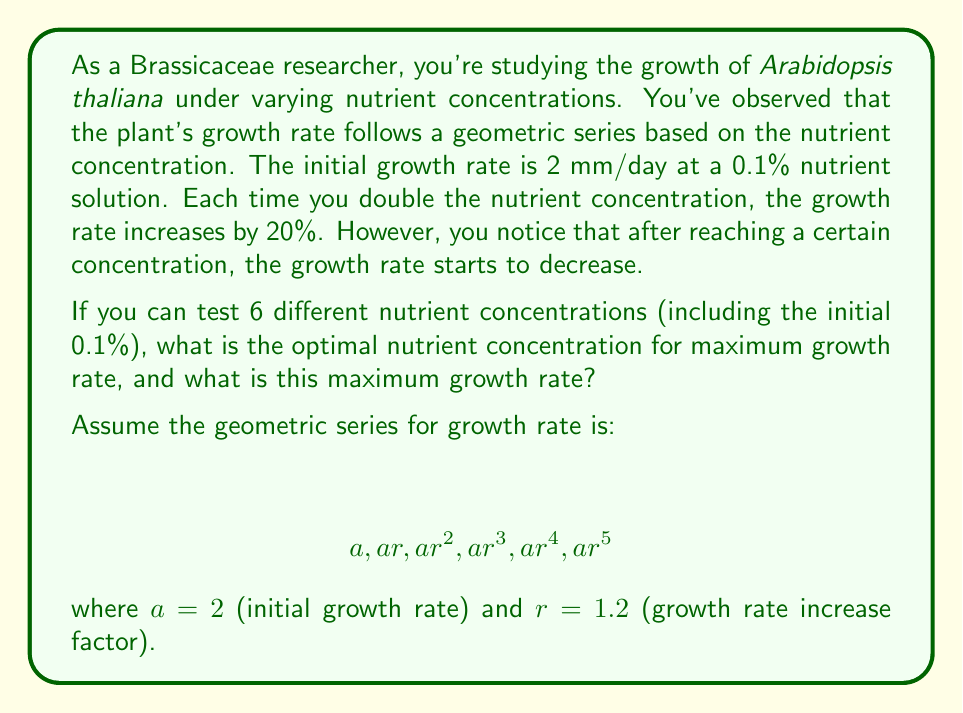Could you help me with this problem? Let's approach this step-by-step:

1) First, we need to calculate the growth rates for each nutrient concentration:

   $a_1 = 2$ mm/day (at 0.1% concentration)
   $a_2 = 2 * 1.2 = 2.4$ mm/day (at 0.2% concentration)
   $a_3 = 2 * 1.2^2 = 2.88$ mm/day (at 0.4% concentration)
   $a_4 = 2 * 1.2^3 = 3.456$ mm/day (at 0.8% concentration)
   $a_5 = 2 * 1.2^4 = 4.1472$ mm/day (at 1.6% concentration)
   $a_6 = 2 * 1.2^5 = 4.97664$ mm/day (at 3.2% concentration)

2) The general term of this geometric sequence is:

   $$ a_n = 2 * 1.2^{n-1} $$

3) To find the maximum value, we need to determine if the sequence is still increasing at the 6th term. We can do this by comparing the 5th and 6th terms:

   $a_6 > a_5$ (4.97664 > 4.1472)

4) Since the 6th term is larger than the 5th, the maximum growth rate occurs at the 6th term.

5) The maximum growth rate is therefore 4.97664 mm/day.

6) The corresponding nutrient concentration is 3.2%, which we can calculate as:

   $0.1\% * 2^5 = 3.2\%$

   This is because we doubled the concentration 5 times from the initial 0.1%.
Answer: The optimal nutrient concentration for maximum growth rate is 3.2%, which yields a maximum growth rate of 4.97664 mm/day. 